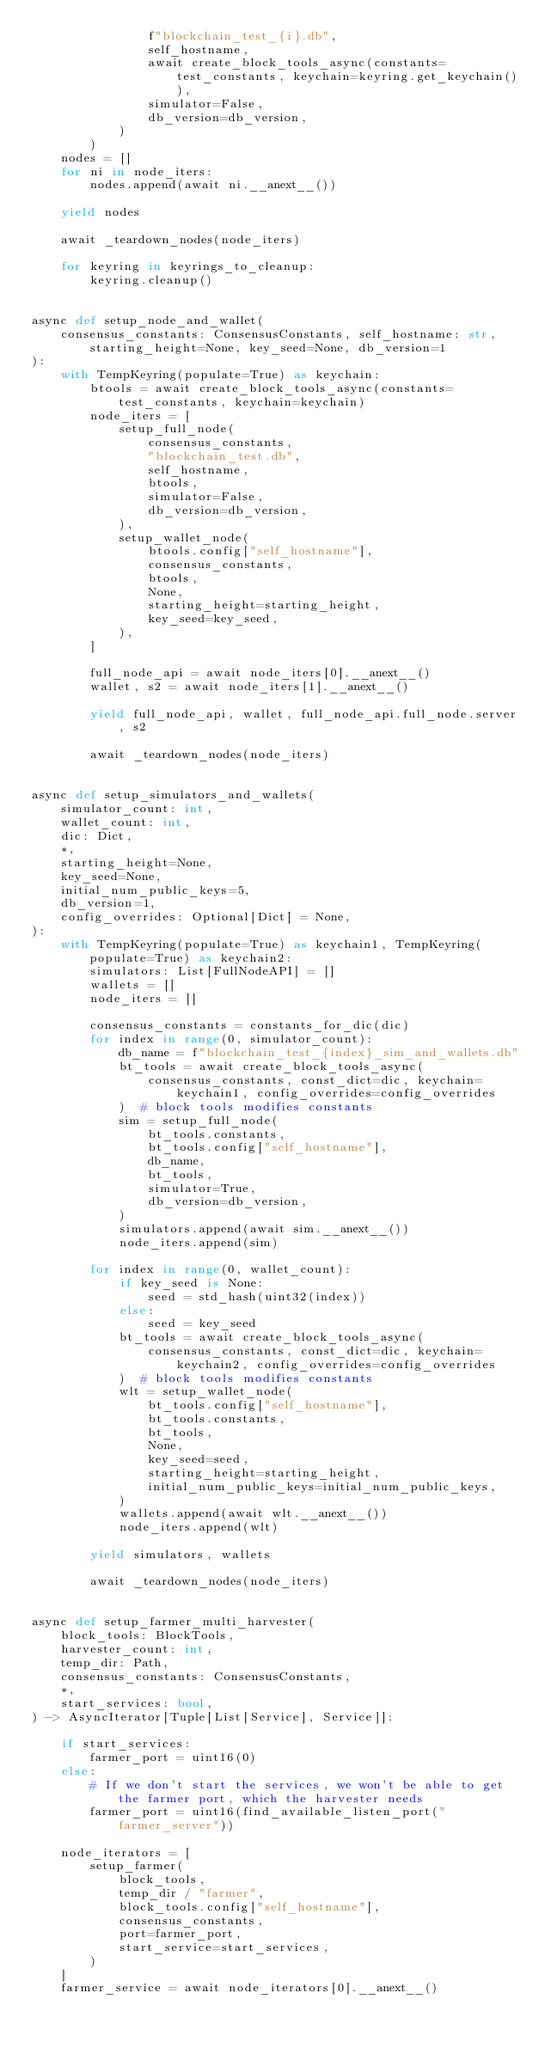<code> <loc_0><loc_0><loc_500><loc_500><_Python_>                f"blockchain_test_{i}.db",
                self_hostname,
                await create_block_tools_async(constants=test_constants, keychain=keyring.get_keychain()),
                simulator=False,
                db_version=db_version,
            )
        )
    nodes = []
    for ni in node_iters:
        nodes.append(await ni.__anext__())

    yield nodes

    await _teardown_nodes(node_iters)

    for keyring in keyrings_to_cleanup:
        keyring.cleanup()


async def setup_node_and_wallet(
    consensus_constants: ConsensusConstants, self_hostname: str, starting_height=None, key_seed=None, db_version=1
):
    with TempKeyring(populate=True) as keychain:
        btools = await create_block_tools_async(constants=test_constants, keychain=keychain)
        node_iters = [
            setup_full_node(
                consensus_constants,
                "blockchain_test.db",
                self_hostname,
                btools,
                simulator=False,
                db_version=db_version,
            ),
            setup_wallet_node(
                btools.config["self_hostname"],
                consensus_constants,
                btools,
                None,
                starting_height=starting_height,
                key_seed=key_seed,
            ),
        ]

        full_node_api = await node_iters[0].__anext__()
        wallet, s2 = await node_iters[1].__anext__()

        yield full_node_api, wallet, full_node_api.full_node.server, s2

        await _teardown_nodes(node_iters)


async def setup_simulators_and_wallets(
    simulator_count: int,
    wallet_count: int,
    dic: Dict,
    *,
    starting_height=None,
    key_seed=None,
    initial_num_public_keys=5,
    db_version=1,
    config_overrides: Optional[Dict] = None,
):
    with TempKeyring(populate=True) as keychain1, TempKeyring(populate=True) as keychain2:
        simulators: List[FullNodeAPI] = []
        wallets = []
        node_iters = []

        consensus_constants = constants_for_dic(dic)
        for index in range(0, simulator_count):
            db_name = f"blockchain_test_{index}_sim_and_wallets.db"
            bt_tools = await create_block_tools_async(
                consensus_constants, const_dict=dic, keychain=keychain1, config_overrides=config_overrides
            )  # block tools modifies constants
            sim = setup_full_node(
                bt_tools.constants,
                bt_tools.config["self_hostname"],
                db_name,
                bt_tools,
                simulator=True,
                db_version=db_version,
            )
            simulators.append(await sim.__anext__())
            node_iters.append(sim)

        for index in range(0, wallet_count):
            if key_seed is None:
                seed = std_hash(uint32(index))
            else:
                seed = key_seed
            bt_tools = await create_block_tools_async(
                consensus_constants, const_dict=dic, keychain=keychain2, config_overrides=config_overrides
            )  # block tools modifies constants
            wlt = setup_wallet_node(
                bt_tools.config["self_hostname"],
                bt_tools.constants,
                bt_tools,
                None,
                key_seed=seed,
                starting_height=starting_height,
                initial_num_public_keys=initial_num_public_keys,
            )
            wallets.append(await wlt.__anext__())
            node_iters.append(wlt)

        yield simulators, wallets

        await _teardown_nodes(node_iters)


async def setup_farmer_multi_harvester(
    block_tools: BlockTools,
    harvester_count: int,
    temp_dir: Path,
    consensus_constants: ConsensusConstants,
    *,
    start_services: bool,
) -> AsyncIterator[Tuple[List[Service], Service]]:

    if start_services:
        farmer_port = uint16(0)
    else:
        # If we don't start the services, we won't be able to get the farmer port, which the harvester needs
        farmer_port = uint16(find_available_listen_port("farmer_server"))

    node_iterators = [
        setup_farmer(
            block_tools,
            temp_dir / "farmer",
            block_tools.config["self_hostname"],
            consensus_constants,
            port=farmer_port,
            start_service=start_services,
        )
    ]
    farmer_service = await node_iterators[0].__anext__()</code> 